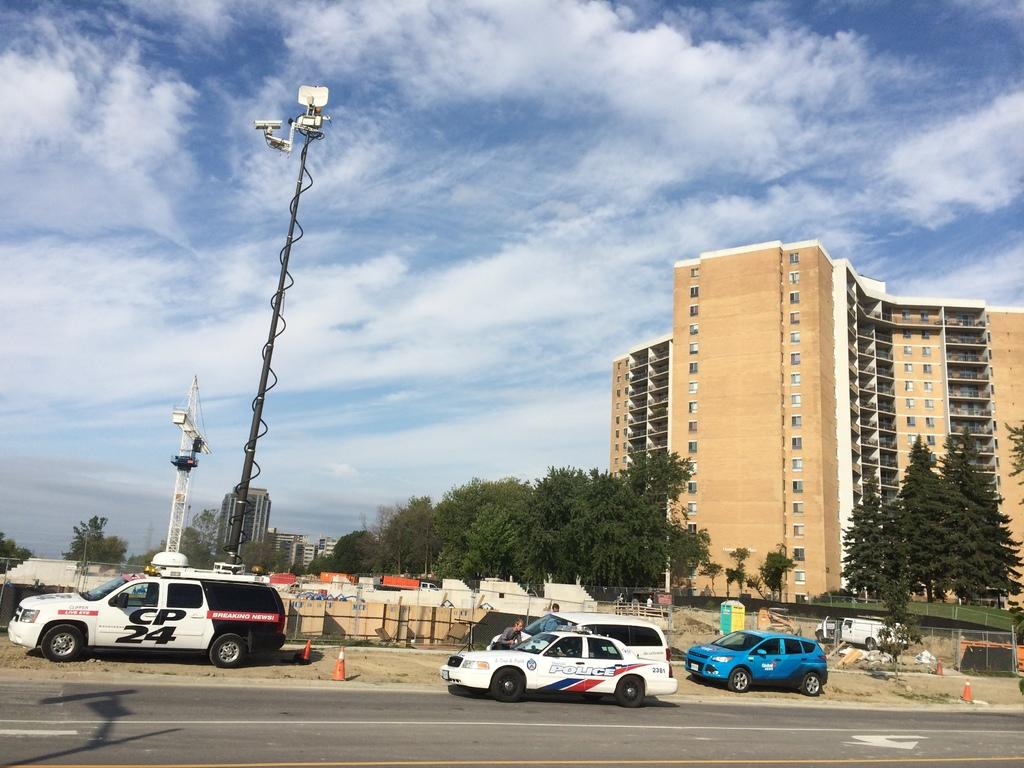What is the main feature of the image? There is a road in the image. What else can be seen on the road? There are vehicles in the image. Are there any objects placed on the road? Traffic cones are present in the image. What type of barriers can be seen in the image? There are fences in the image. What structures are visible in the background? Buildings are visible in the image. What type of vegetation is present in the image? Trees are present in the image. What is the tall, vertical object in the image? There is a pole in the image. Can you describe the unspecified objects in the image? Unfortunately, the facts provided do not specify the nature of these objects. What is visible in the sky in the background of the image? The sky is visible in the background of the image, and clouds are present in the sky. What type of floor can be seen in the image? There is no floor present in the image, as it primarily features a road and its surroundings. 